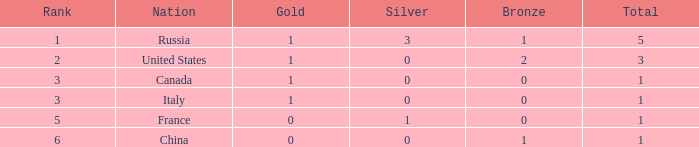When there are 1 gold and 1 silver, how many golds are there in total? 1.0. 